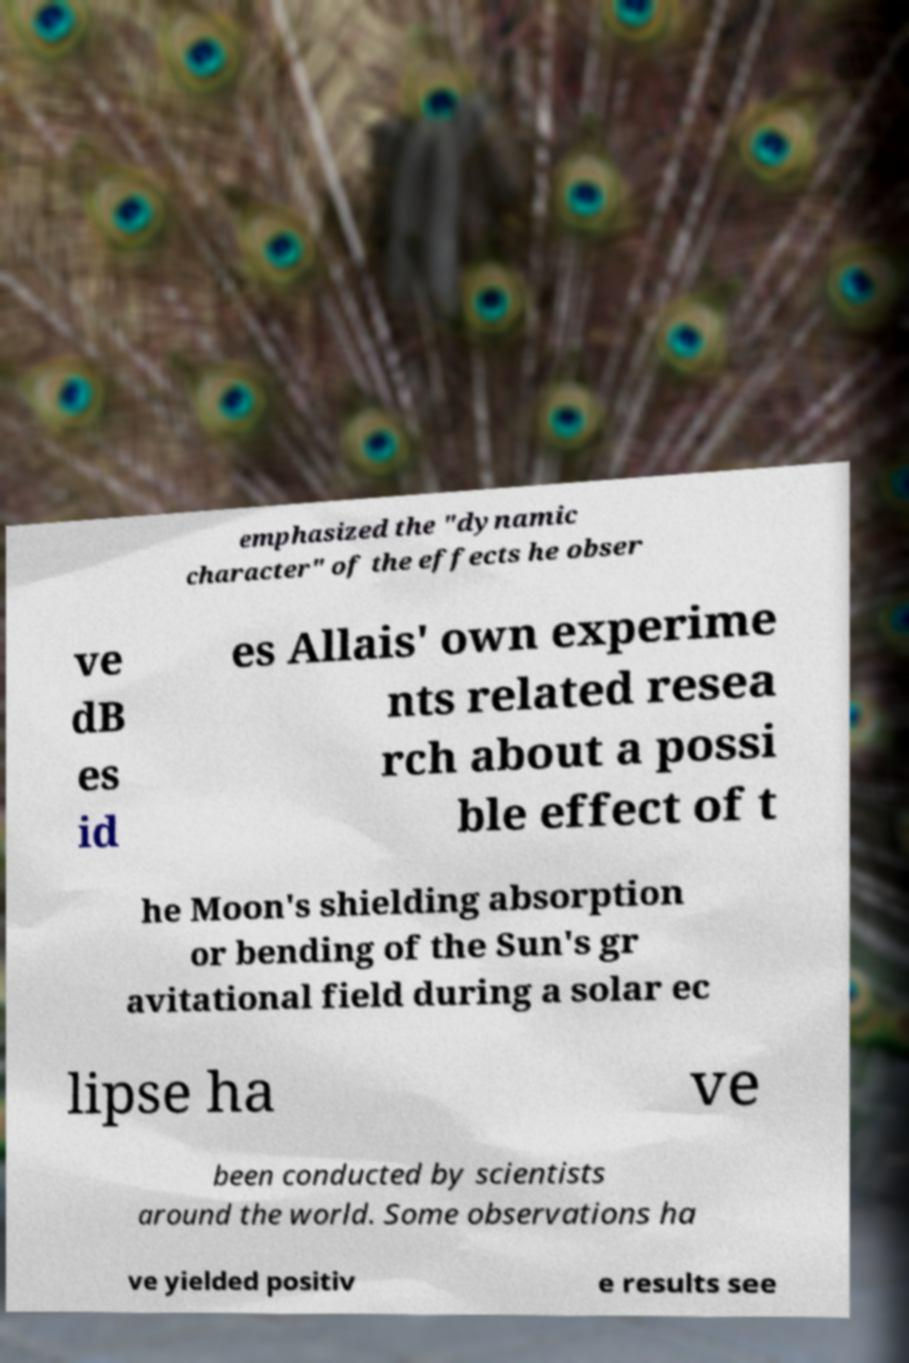Could you extract and type out the text from this image? emphasized the "dynamic character" of the effects he obser ve dB es id es Allais' own experime nts related resea rch about a possi ble effect of t he Moon's shielding absorption or bending of the Sun's gr avitational field during a solar ec lipse ha ve been conducted by scientists around the world. Some observations ha ve yielded positiv e results see 